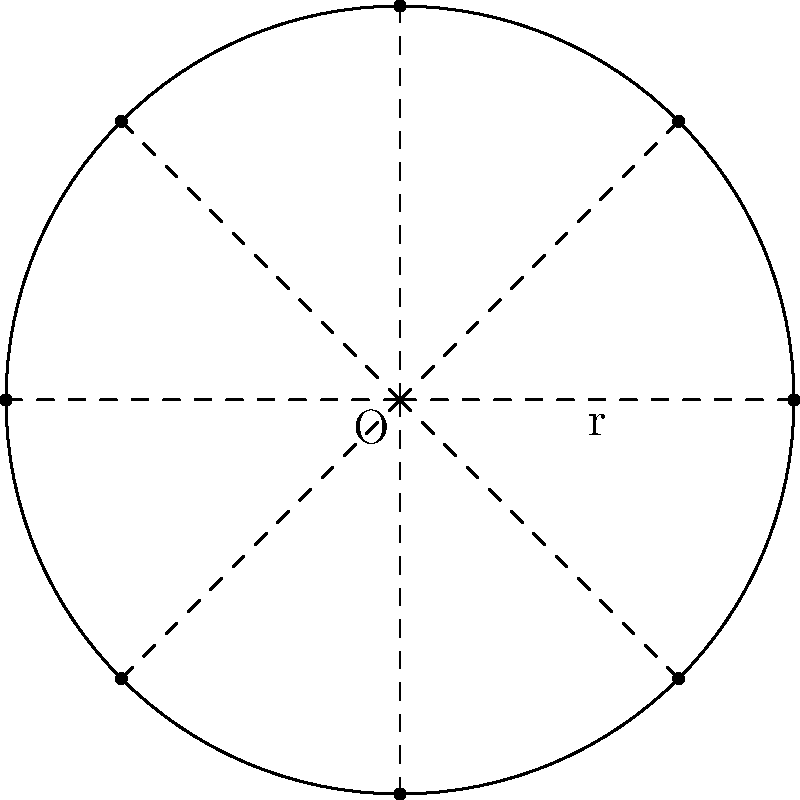A circular solar panel array with radius $r$ needs to be designed with 8 identical solar cells arranged around its perimeter. To maximize efficiency, the cells should be equally spaced. Using polar coordinates, determine the angular position $\theta$ (in radians) of each solar cell, assuming the first cell is placed at $\theta = 0$. Express your answer in terms of $\pi$. To solve this problem, we'll follow these steps:

1) In a circle, there are $2\pi$ radians in total.

2) We need to divide these $2\pi$ radians equally among 8 solar cells.

3) The angular separation between each cell will be:
   $\Delta\theta = \frac{2\pi}{8} = \frac{\pi}{4}$ radians

4) Starting from $\theta = 0$, the angular positions of the 8 cells will be:
   
   Cell 1: $\theta_1 = 0$
   Cell 2: $\theta_2 = \frac{\pi}{4}$
   Cell 3: $\theta_3 = \frac{2\pi}{4} = \frac{\pi}{2}$
   Cell 4: $\theta_4 = \frac{3\pi}{4}$
   Cell 5: $\theta_5 = \frac{4\pi}{4} = \pi$
   Cell 6: $\theta_6 = \frac{5\pi}{4}$
   Cell 7: $\theta_7 = \frac{6\pi}{4} = \frac{3\pi}{2}$
   Cell 8: $\theta_8 = \frac{7\pi}{4}$

5) The general formula for the angular position of the $n$th cell (where $n$ goes from 1 to 8) is:

   $\theta_n = \frac{(n-1)\pi}{4}$

This arrangement ensures equal spacing between cells, maximizing the efficiency of the circular solar panel array.
Answer: $\theta_n = \frac{(n-1)\pi}{4}$, where $n = 1, 2, ..., 8$ 